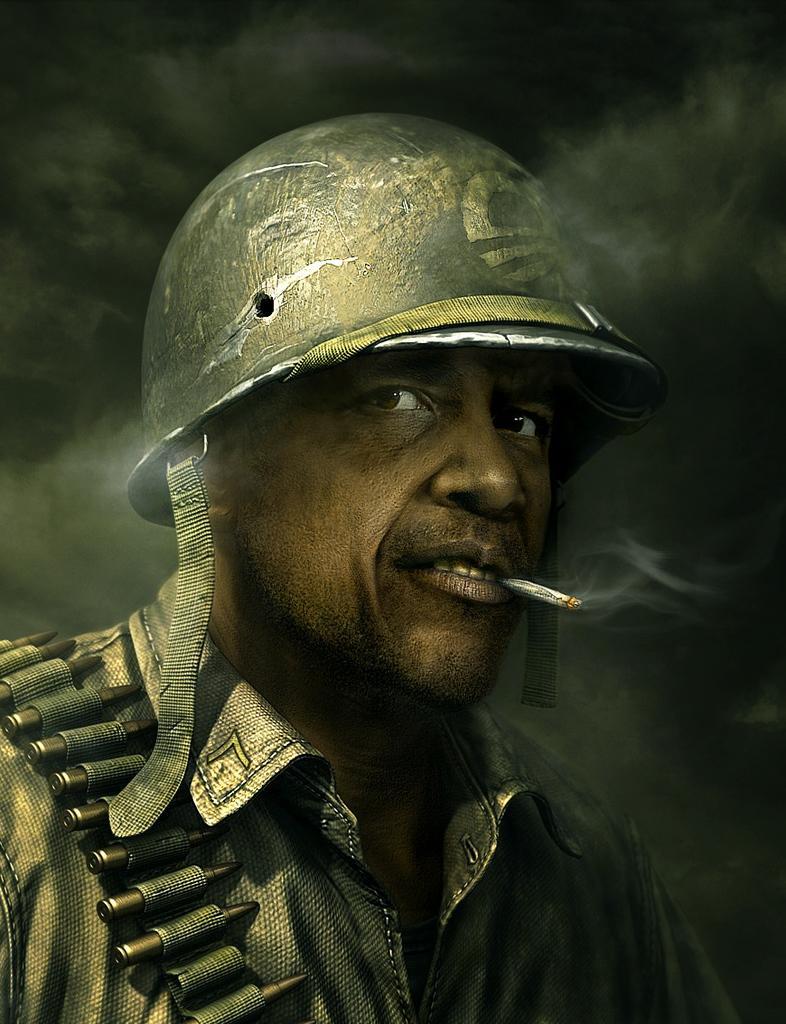Describe this image in one or two sentences. In this image there is a man. There is a helmet on his head. There is a cigarette in his mouth. To the left there is a bullet belt on him. The background is dark. 